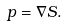Convert formula to latex. <formula><loc_0><loc_0><loc_500><loc_500>p = \nabla S .</formula> 